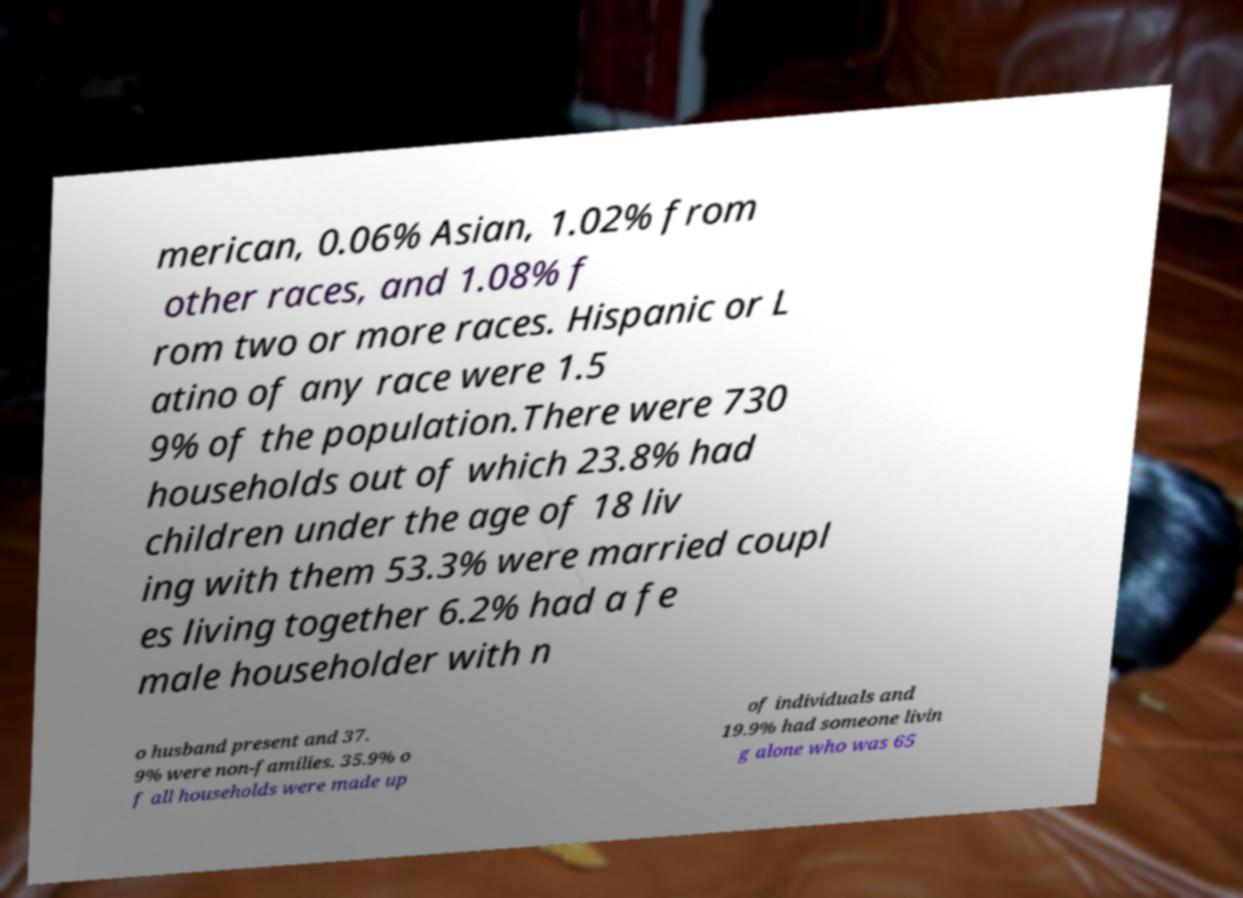Could you assist in decoding the text presented in this image and type it out clearly? merican, 0.06% Asian, 1.02% from other races, and 1.08% f rom two or more races. Hispanic or L atino of any race were 1.5 9% of the population.There were 730 households out of which 23.8% had children under the age of 18 liv ing with them 53.3% were married coupl es living together 6.2% had a fe male householder with n o husband present and 37. 9% were non-families. 35.9% o f all households were made up of individuals and 19.9% had someone livin g alone who was 65 